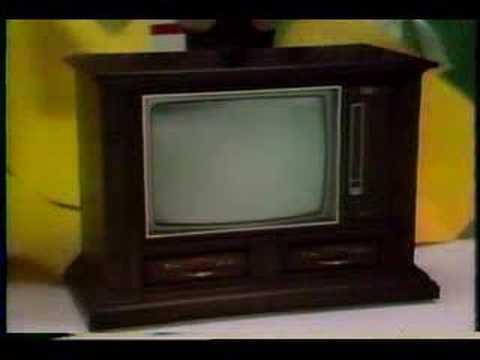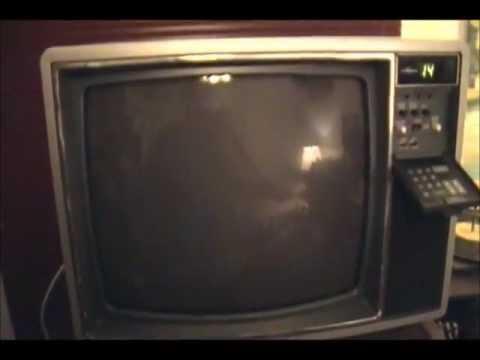The first image is the image on the left, the second image is the image on the right. For the images displayed, is the sentence "One of the televsions is on." factually correct? Answer yes or no. No. 